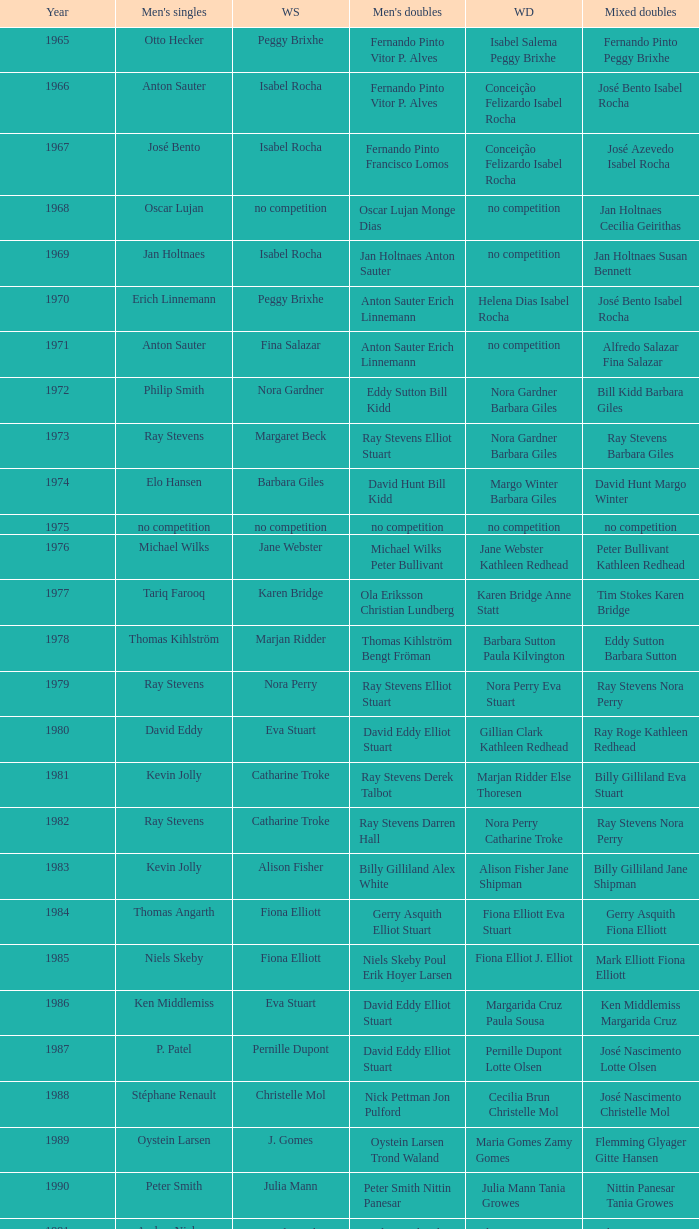What is the average year with alfredo salazar fina salazar in mixed doubles? 1971.0. 